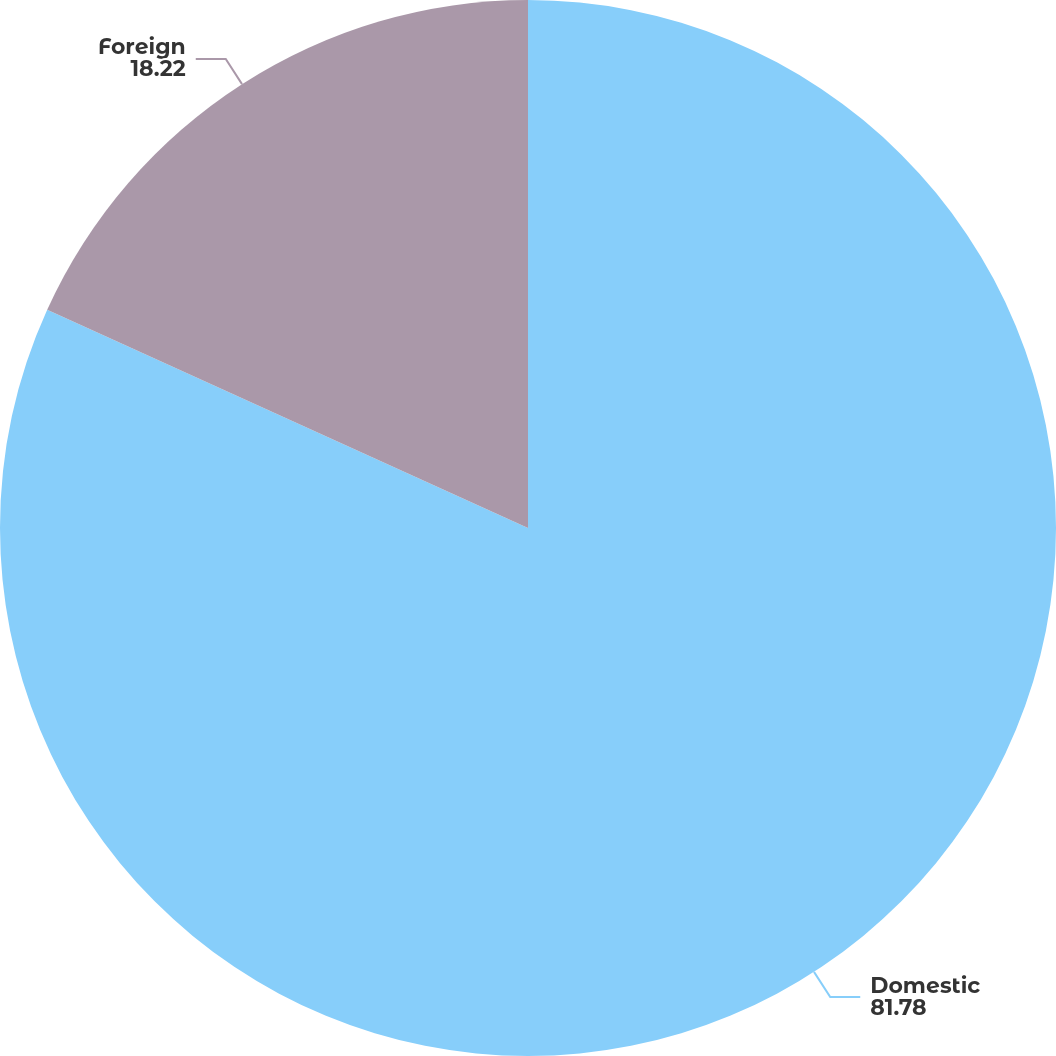Convert chart to OTSL. <chart><loc_0><loc_0><loc_500><loc_500><pie_chart><fcel>Domestic<fcel>Foreign<nl><fcel>81.78%<fcel>18.22%<nl></chart> 